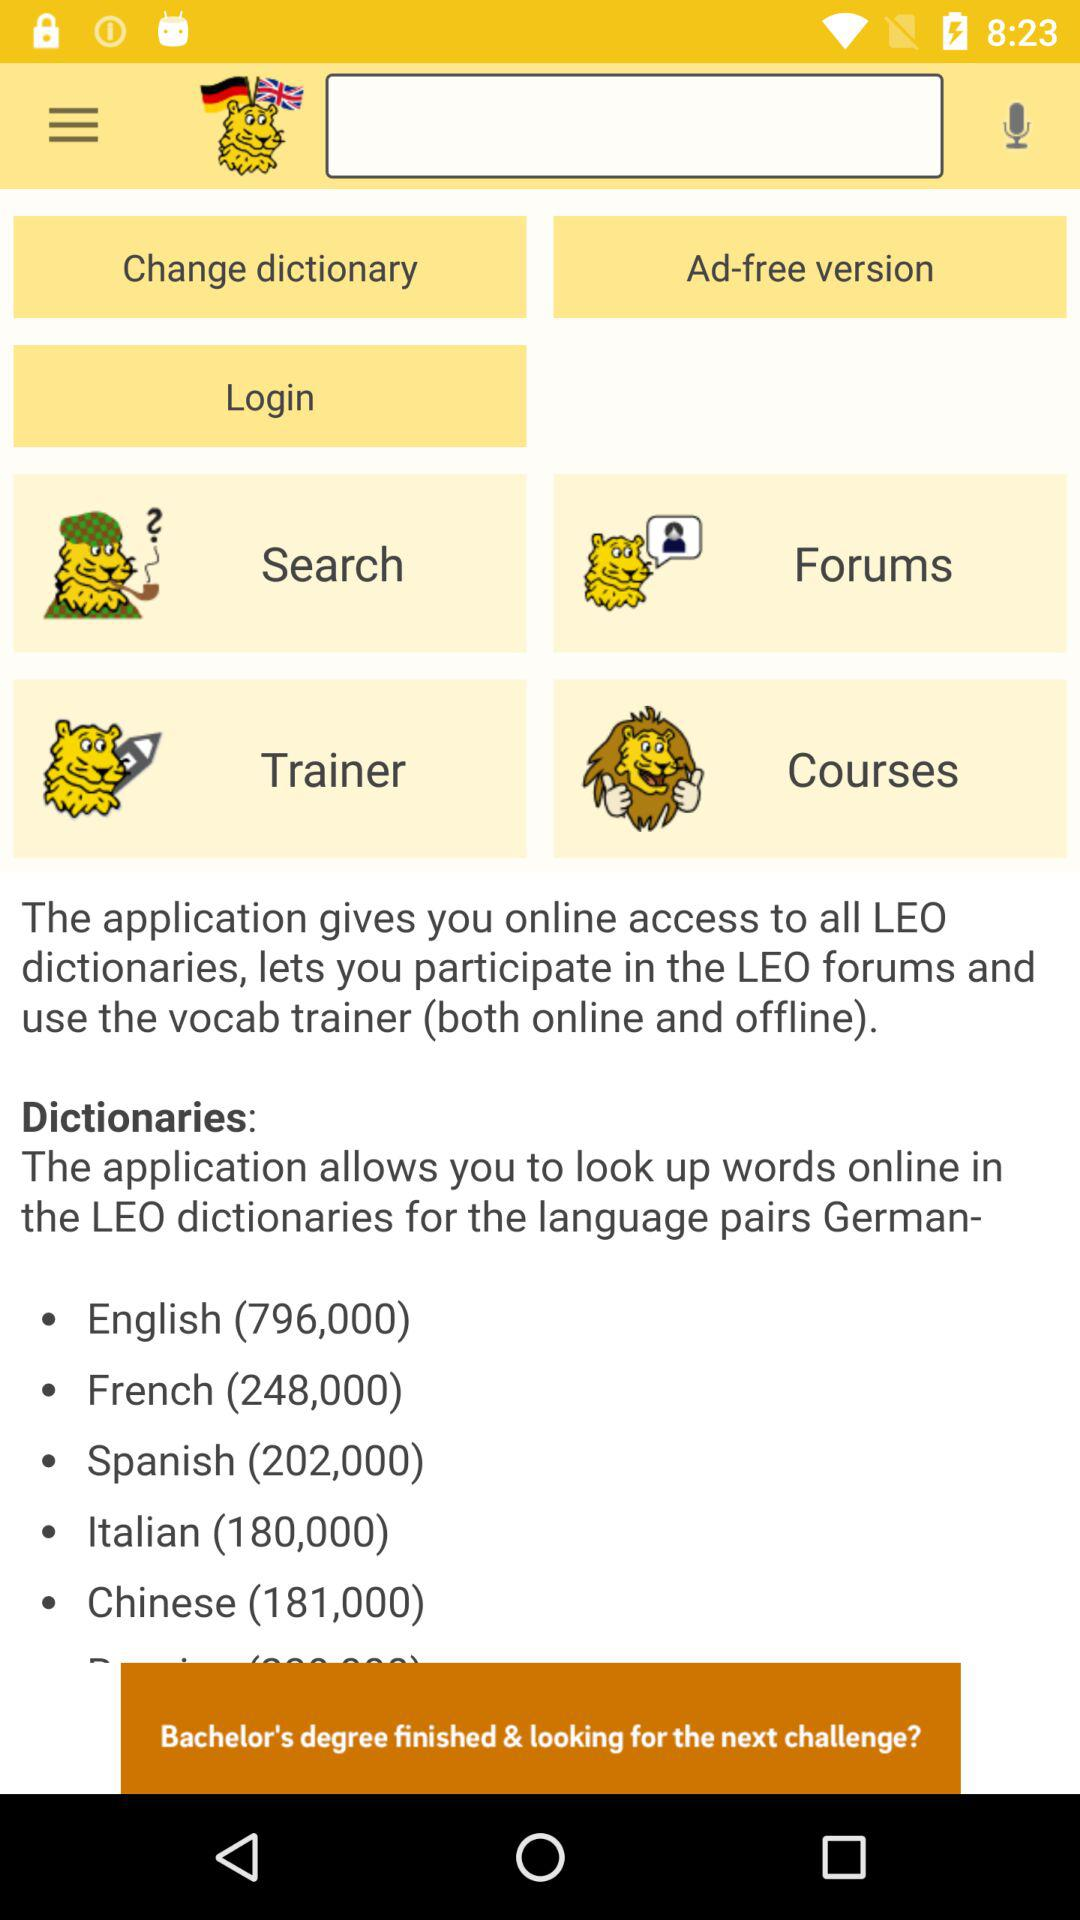How many French words are there? There are 248,000 French words. 